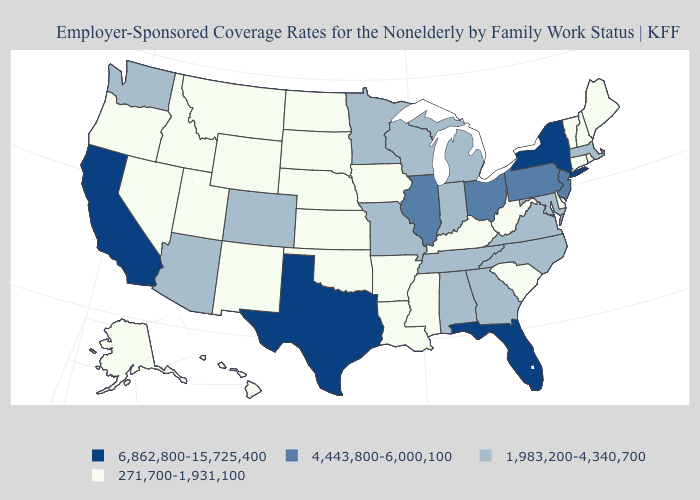What is the lowest value in states that border Massachusetts?
Give a very brief answer. 271,700-1,931,100. Does Montana have the highest value in the West?
Be succinct. No. Which states have the lowest value in the USA?
Be succinct. Alaska, Arkansas, Connecticut, Delaware, Hawaii, Idaho, Iowa, Kansas, Kentucky, Louisiana, Maine, Mississippi, Montana, Nebraska, Nevada, New Hampshire, New Mexico, North Dakota, Oklahoma, Oregon, Rhode Island, South Carolina, South Dakota, Utah, Vermont, West Virginia, Wyoming. What is the value of Michigan?
Quick response, please. 1,983,200-4,340,700. Name the states that have a value in the range 1,983,200-4,340,700?
Give a very brief answer. Alabama, Arizona, Colorado, Georgia, Indiana, Maryland, Massachusetts, Michigan, Minnesota, Missouri, North Carolina, Tennessee, Virginia, Washington, Wisconsin. What is the value of Connecticut?
Quick response, please. 271,700-1,931,100. Does Georgia have the same value as Alabama?
Be succinct. Yes. Among the states that border New York , which have the lowest value?
Concise answer only. Connecticut, Vermont. Does Connecticut have the lowest value in the Northeast?
Be succinct. Yes. Does Rhode Island have the same value as Massachusetts?
Be succinct. No. Does Texas have the highest value in the USA?
Quick response, please. Yes. Does Alabama have the same value as Colorado?
Short answer required. Yes. Name the states that have a value in the range 271,700-1,931,100?
Write a very short answer. Alaska, Arkansas, Connecticut, Delaware, Hawaii, Idaho, Iowa, Kansas, Kentucky, Louisiana, Maine, Mississippi, Montana, Nebraska, Nevada, New Hampshire, New Mexico, North Dakota, Oklahoma, Oregon, Rhode Island, South Carolina, South Dakota, Utah, Vermont, West Virginia, Wyoming. What is the lowest value in the MidWest?
Keep it brief. 271,700-1,931,100. What is the highest value in the MidWest ?
Quick response, please. 4,443,800-6,000,100. 